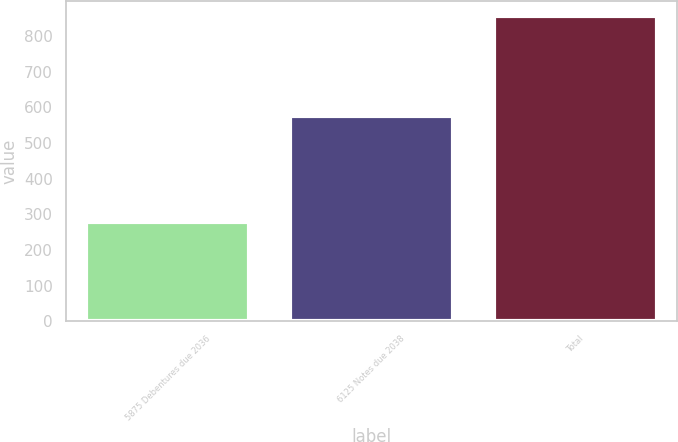Convert chart. <chart><loc_0><loc_0><loc_500><loc_500><bar_chart><fcel>5875 Debentures due 2036<fcel>6125 Notes due 2038<fcel>Total<nl><fcel>278<fcel>577<fcel>855<nl></chart> 